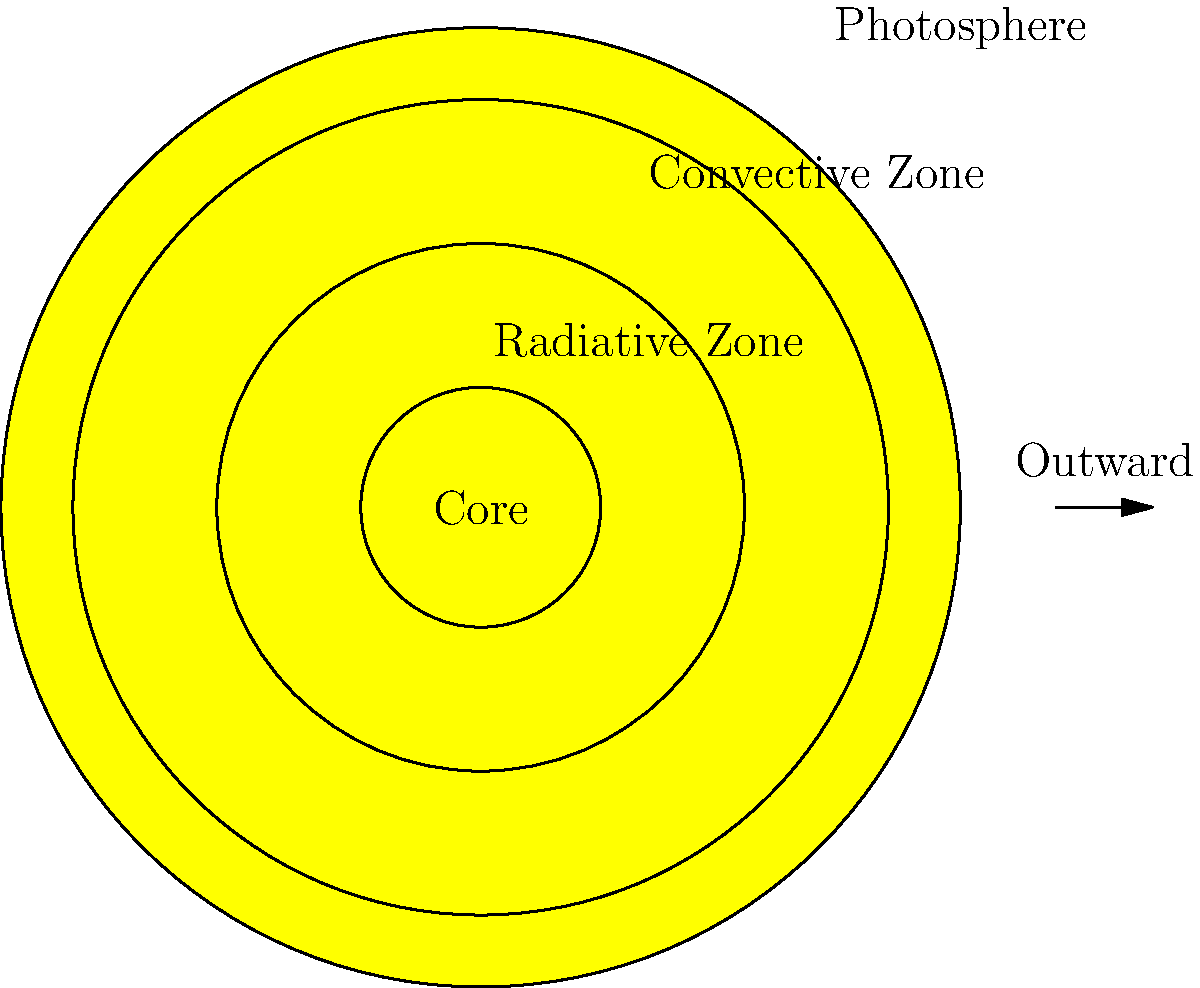In the context of energy transfer within the Sun's structure, which layer plays a crucial role in redistributing energy through rising and falling plasma, and how might this process influence public discourse on climate change policies? 1. The Sun's structure consists of several layers, each with distinct properties and functions:
   - Core: Where nuclear fusion occurs, generating energy
   - Radiative Zone: Where energy is transferred through radiation
   - Convective Zone: Where energy is transferred through convection
   - Photosphere: The visible surface of the Sun

2. The Convective Zone is the layer that redistributes energy through rising and falling plasma:
   - Hot plasma rises from the bottom of the convective zone
   - As it reaches the surface, it cools and sinks back down
   - This creates a cyclical motion, effectively transferring energy outward

3. The convection process in the Sun is similar to convection currents in Earth's atmosphere and oceans, which play a significant role in climate systems.

4. Understanding solar convection can inform climate change discussions:
   - It provides a model for understanding energy transfer in Earth's systems
   - Helps explain the Sun's influence on Earth's climate
   - Can be used to counter misconceptions about solar activity and climate change

5. In the context of public policy:
   - Knowledge of solar physics can inform debates on climate change policies
   - It can help policymakers understand the complexities of climate systems
   - This understanding can lead to more informed decision-making on energy and environmental policies

6. For a political reporter investigating conservative think tanks:
   - Understanding this process can help evaluate claims made about solar influence on climate
   - It can provide a scientific basis for fact-checking policy proposals related to climate change
   - This knowledge can be used to analyze the scientific validity of arguments presented by think tanks on climate policy
Answer: Convective Zone; informs climate policy debates by illustrating energy transfer mechanisms. 